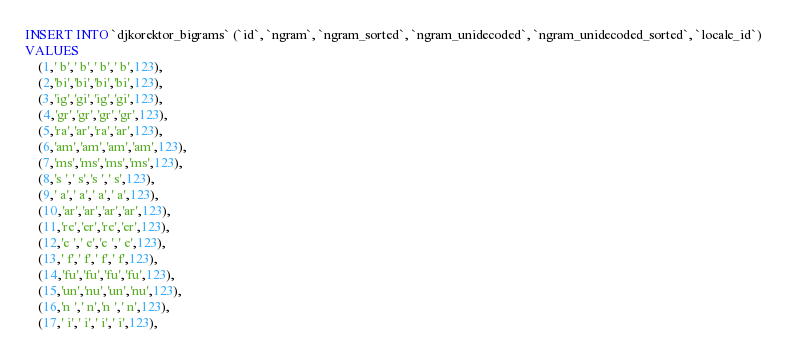<code> <loc_0><loc_0><loc_500><loc_500><_SQL_>INSERT INTO `djkorektor_bigrams` (`id`, `ngram`, `ngram_sorted`, `ngram_unidecoded`, `ngram_unidecoded_sorted`, `locale_id`)
VALUES
	(1,' b',' b',' b',' b',123),
	(2,'bi','bi','bi','bi',123),
	(3,'ig','gi','ig','gi',123),
	(4,'gr','gr','gr','gr',123),
	(5,'ra','ar','ra','ar',123),
	(6,'am','am','am','am',123),
	(7,'ms','ms','ms','ms',123),
	(8,'s ',' s','s ',' s',123),
	(9,' a',' a',' a',' a',123),
	(10,'ar','ar','ar','ar',123),
	(11,'re','er','re','er',123),
	(12,'e ',' e','e ',' e',123),
	(13,' f',' f',' f',' f',123),
	(14,'fu','fu','fu','fu',123),
	(15,'un','nu','un','nu',123),
	(16,'n ',' n','n ',' n',123),
	(17,' i',' i',' i',' i',123),</code> 